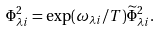Convert formula to latex. <formula><loc_0><loc_0><loc_500><loc_500>\Phi ^ { 2 } _ { \lambda i } = \exp ( \omega _ { \lambda i } / T ) \widetilde { \Phi } ^ { 2 } _ { \lambda i } .</formula> 